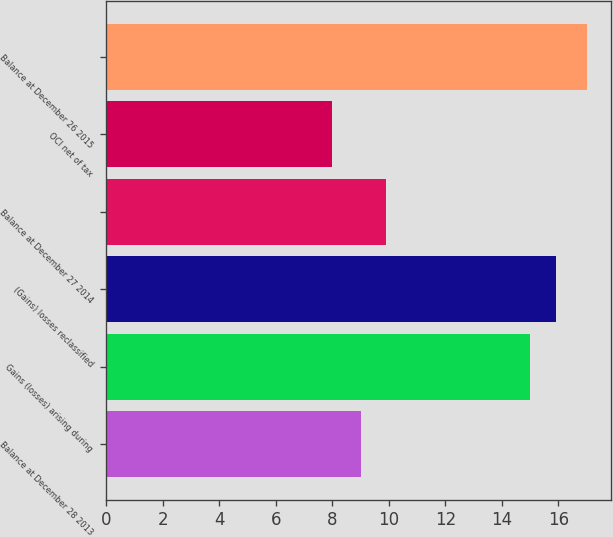Convert chart to OTSL. <chart><loc_0><loc_0><loc_500><loc_500><bar_chart><fcel>Balance at December 28 2013<fcel>Gains (losses) arising during<fcel>(Gains) losses reclassified<fcel>Balance at December 27 2014<fcel>OCI net of tax<fcel>Balance at December 26 2015<nl><fcel>9<fcel>15<fcel>15.9<fcel>9.9<fcel>8<fcel>17<nl></chart> 